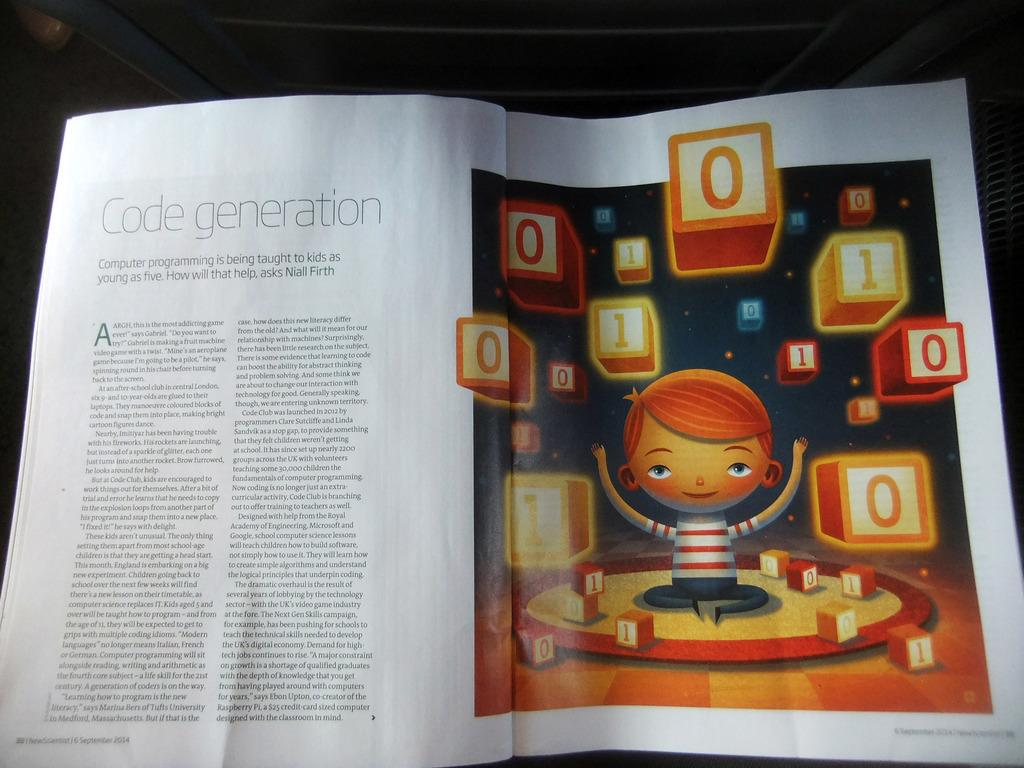Provide a one-sentence caption for the provided image. A magazine is on a flat surface and is open to an article on computer coding. 